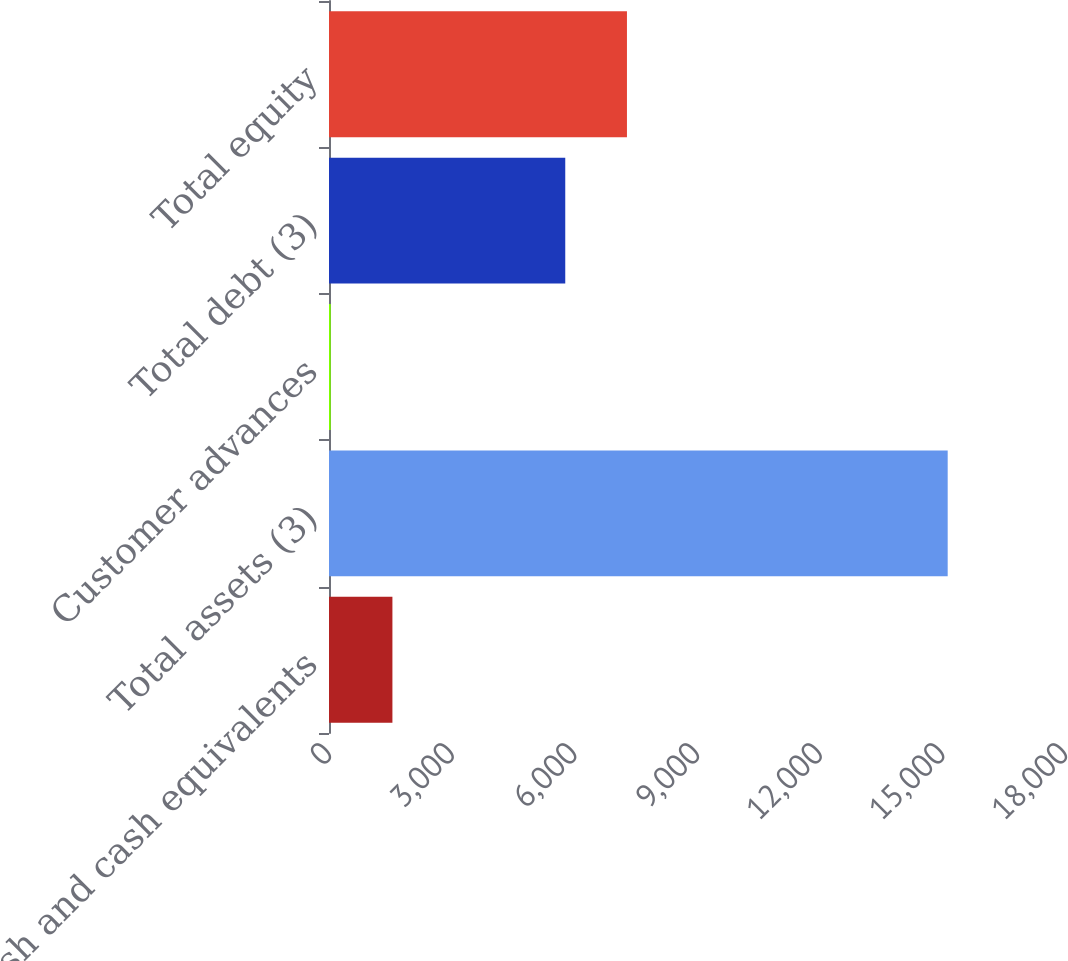<chart> <loc_0><loc_0><loc_500><loc_500><bar_chart><fcel>Cash and cash equivalents<fcel>Total assets (3)<fcel>Customer advances<fcel>Total debt (3)<fcel>Total equity<nl><fcel>1550.9<fcel>15131<fcel>42<fcel>5778<fcel>7286.9<nl></chart> 